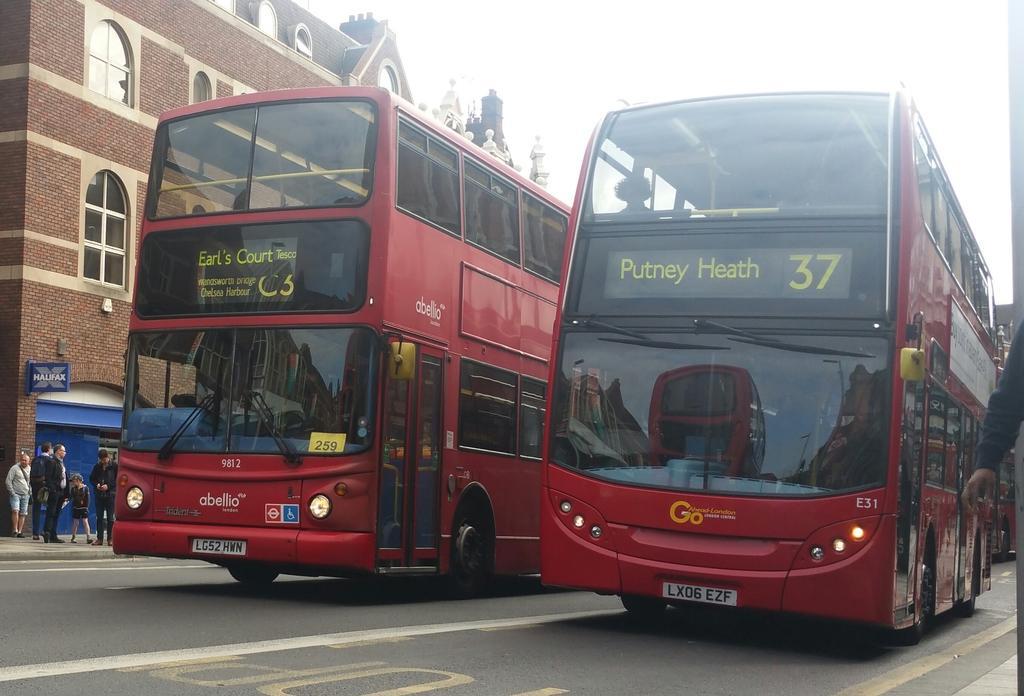In one or two sentences, can you explain what this image depicts? These are the 2 buses which are in red color on the road, On the left side few people are standing on the foot path and this is a building. 